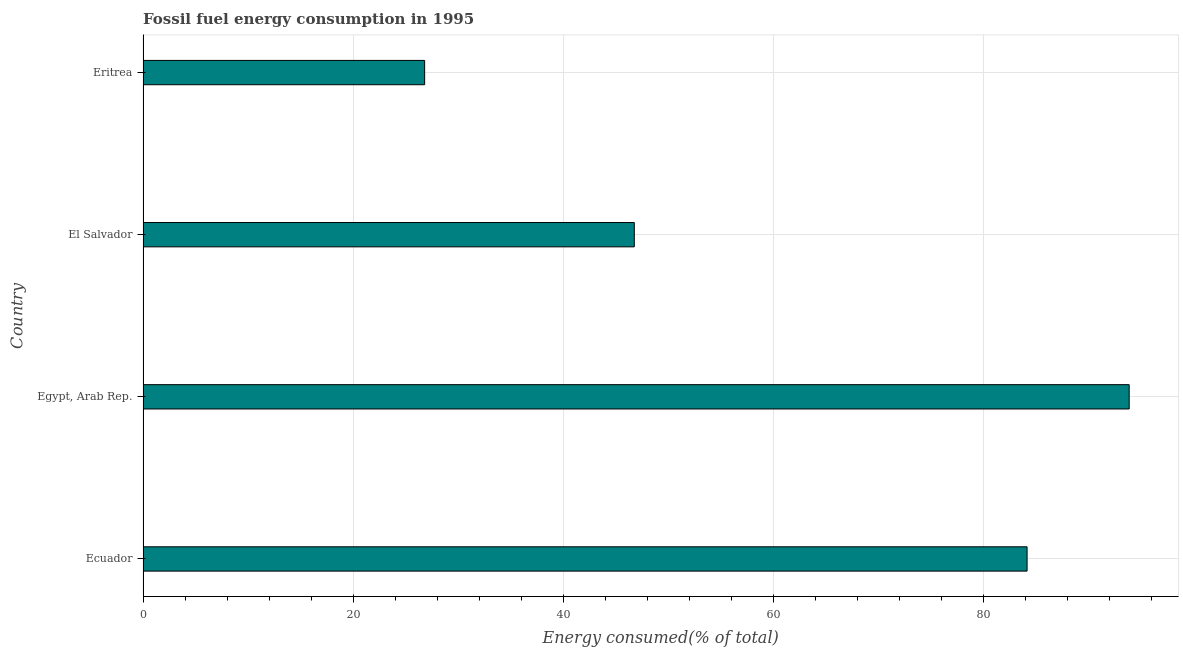Does the graph contain any zero values?
Your response must be concise. No. Does the graph contain grids?
Provide a succinct answer. Yes. What is the title of the graph?
Ensure brevity in your answer.  Fossil fuel energy consumption in 1995. What is the label or title of the X-axis?
Offer a very short reply. Energy consumed(% of total). What is the label or title of the Y-axis?
Keep it short and to the point. Country. What is the fossil fuel energy consumption in El Salvador?
Your answer should be compact. 46.74. Across all countries, what is the maximum fossil fuel energy consumption?
Your answer should be very brief. 93.83. Across all countries, what is the minimum fossil fuel energy consumption?
Provide a succinct answer. 26.79. In which country was the fossil fuel energy consumption maximum?
Offer a very short reply. Egypt, Arab Rep. In which country was the fossil fuel energy consumption minimum?
Ensure brevity in your answer.  Eritrea. What is the sum of the fossil fuel energy consumption?
Provide a succinct answer. 251.48. What is the difference between the fossil fuel energy consumption in Ecuador and El Salvador?
Make the answer very short. 37.37. What is the average fossil fuel energy consumption per country?
Offer a very short reply. 62.87. What is the median fossil fuel energy consumption?
Your response must be concise. 65.43. What is the ratio of the fossil fuel energy consumption in Egypt, Arab Rep. to that in El Salvador?
Keep it short and to the point. 2.01. Is the fossil fuel energy consumption in Ecuador less than that in Eritrea?
Offer a very short reply. No. What is the difference between the highest and the second highest fossil fuel energy consumption?
Ensure brevity in your answer.  9.71. Is the sum of the fossil fuel energy consumption in Ecuador and Eritrea greater than the maximum fossil fuel energy consumption across all countries?
Your answer should be compact. Yes. What is the difference between the highest and the lowest fossil fuel energy consumption?
Give a very brief answer. 67.04. Are all the bars in the graph horizontal?
Provide a succinct answer. Yes. What is the difference between two consecutive major ticks on the X-axis?
Offer a terse response. 20. What is the Energy consumed(% of total) in Ecuador?
Ensure brevity in your answer.  84.11. What is the Energy consumed(% of total) in Egypt, Arab Rep.?
Give a very brief answer. 93.83. What is the Energy consumed(% of total) of El Salvador?
Your answer should be very brief. 46.74. What is the Energy consumed(% of total) in Eritrea?
Offer a very short reply. 26.79. What is the difference between the Energy consumed(% of total) in Ecuador and Egypt, Arab Rep.?
Your answer should be very brief. -9.72. What is the difference between the Energy consumed(% of total) in Ecuador and El Salvador?
Offer a very short reply. 37.37. What is the difference between the Energy consumed(% of total) in Ecuador and Eritrea?
Give a very brief answer. 57.32. What is the difference between the Energy consumed(% of total) in Egypt, Arab Rep. and El Salvador?
Offer a very short reply. 47.09. What is the difference between the Energy consumed(% of total) in Egypt, Arab Rep. and Eritrea?
Make the answer very short. 67.04. What is the difference between the Energy consumed(% of total) in El Salvador and Eritrea?
Give a very brief answer. 19.95. What is the ratio of the Energy consumed(% of total) in Ecuador to that in Egypt, Arab Rep.?
Give a very brief answer. 0.9. What is the ratio of the Energy consumed(% of total) in Ecuador to that in Eritrea?
Your answer should be compact. 3.14. What is the ratio of the Energy consumed(% of total) in Egypt, Arab Rep. to that in El Salvador?
Your answer should be very brief. 2.01. What is the ratio of the Energy consumed(% of total) in Egypt, Arab Rep. to that in Eritrea?
Make the answer very short. 3.5. What is the ratio of the Energy consumed(% of total) in El Salvador to that in Eritrea?
Give a very brief answer. 1.75. 